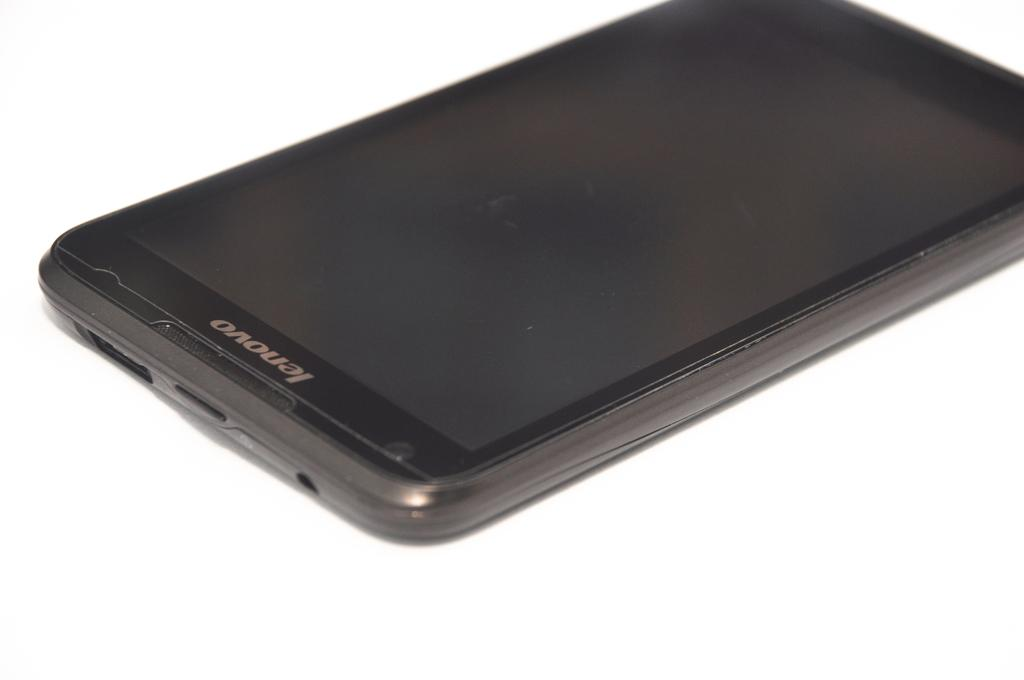Provide a one-sentence caption for the provided image. A black Lenovo smartphone lies on a white background. 